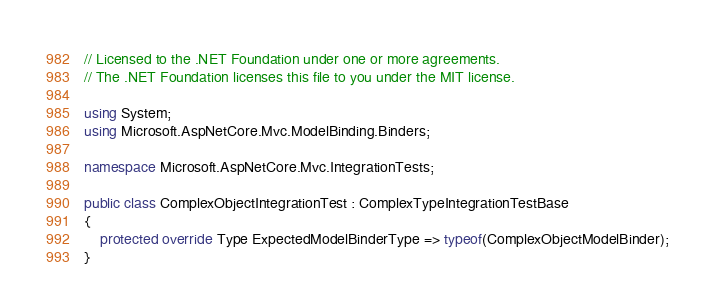<code> <loc_0><loc_0><loc_500><loc_500><_C#_>// Licensed to the .NET Foundation under one or more agreements.
// The .NET Foundation licenses this file to you under the MIT license.

using System;
using Microsoft.AspNetCore.Mvc.ModelBinding.Binders;

namespace Microsoft.AspNetCore.Mvc.IntegrationTests;

public class ComplexObjectIntegrationTest : ComplexTypeIntegrationTestBase
{
    protected override Type ExpectedModelBinderType => typeof(ComplexObjectModelBinder);
}
</code> 